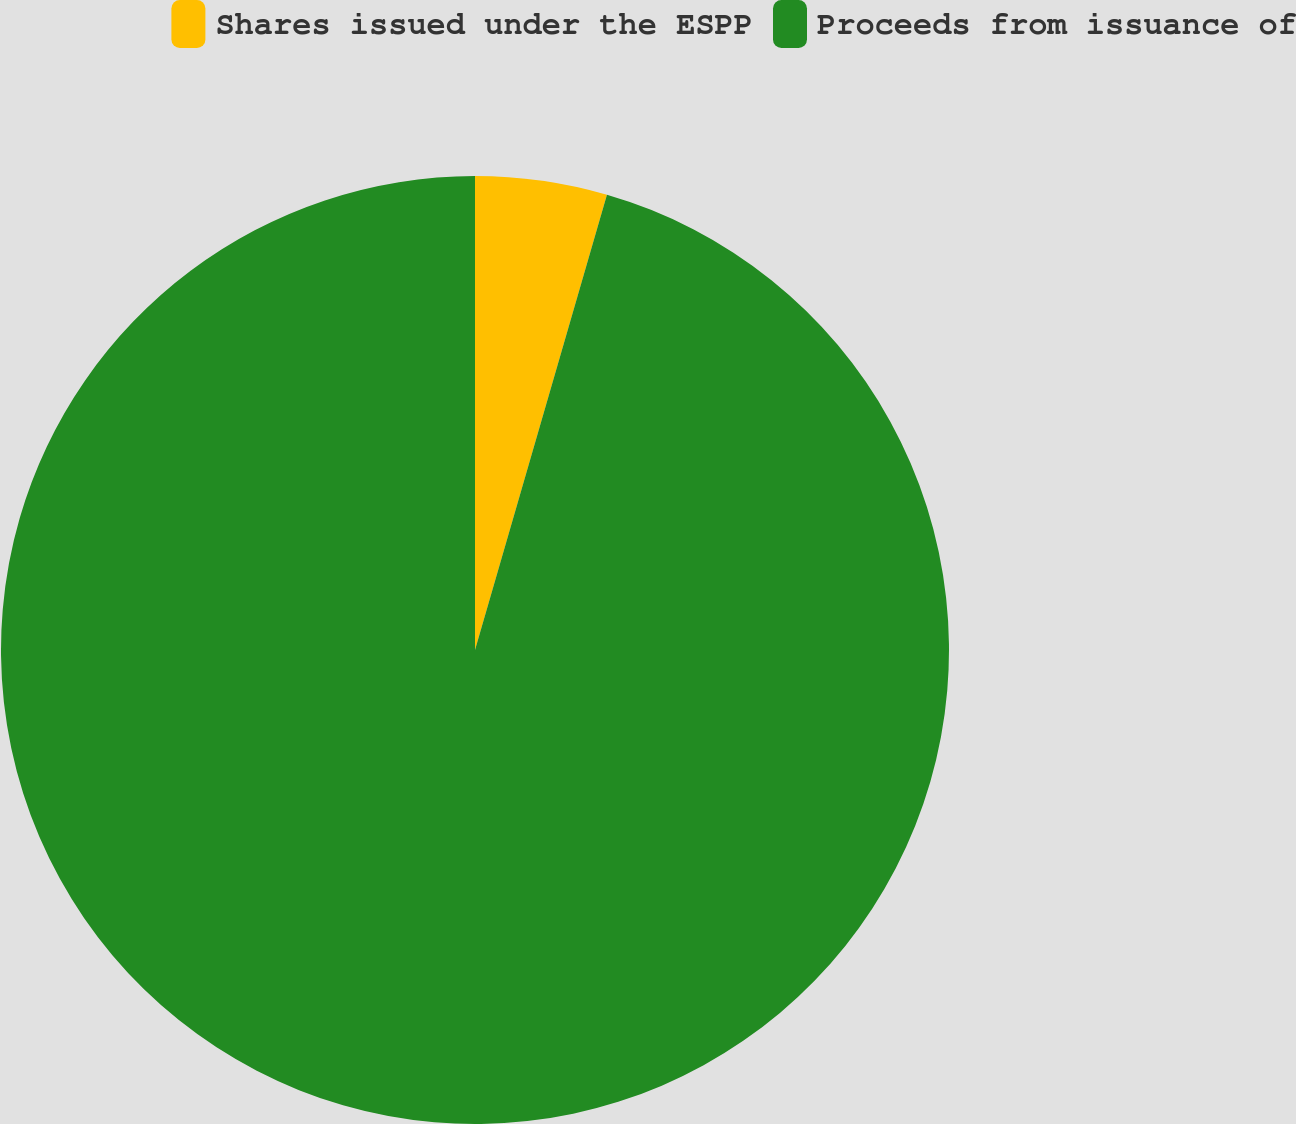Convert chart to OTSL. <chart><loc_0><loc_0><loc_500><loc_500><pie_chart><fcel>Shares issued under the ESPP<fcel>Proceeds from issuance of<nl><fcel>4.49%<fcel>95.51%<nl></chart> 